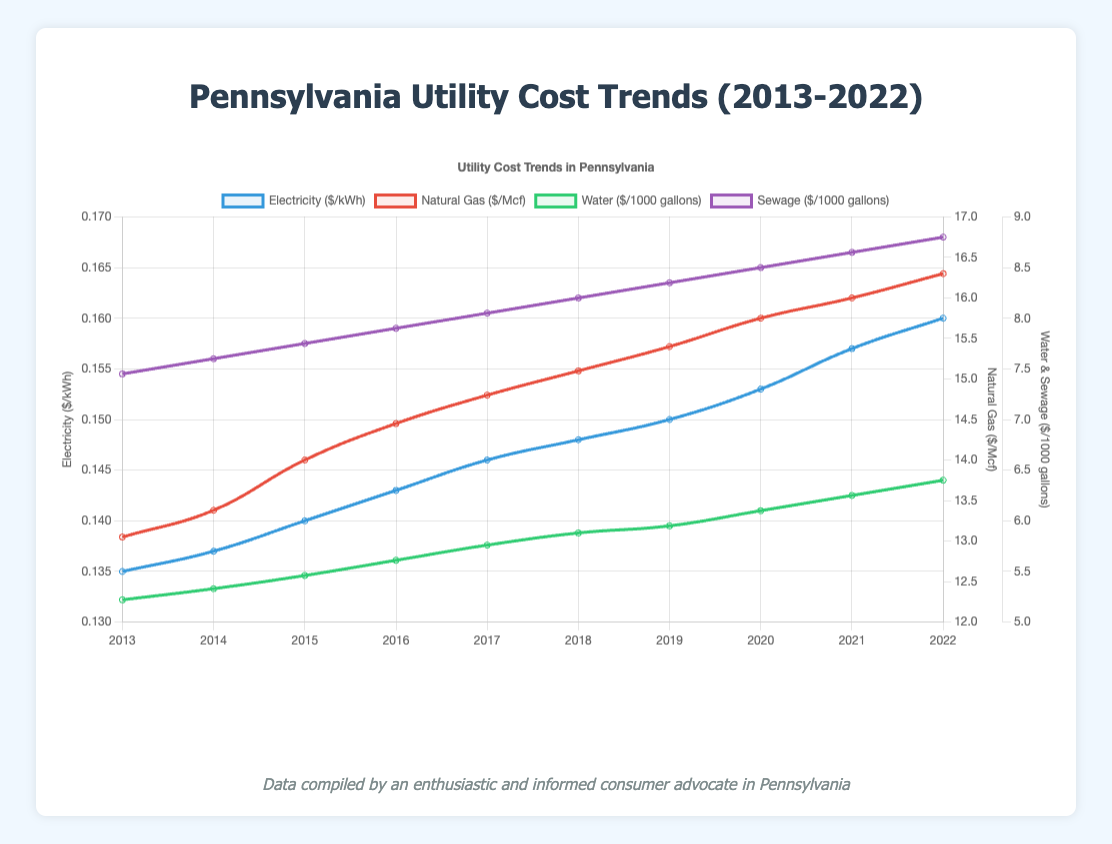Which utility had the highest cost in 2013? Observe the plot points for 2013. The values are: Electricity: 0.135 $/kWh, Natural Gas: 13.05 $/Mcf, Water: 5.22 $/1000 gallons, Sewage: 7.45 $/1000 gallons. Natural Gas is the highest.
Answer: Natural Gas How much did the cost of water increase from 2013 to 2022? Find the values for water in 2013 and 2022. Water cost in 2013 was 5.22 $/1000 gallons, and in 2022 it was 6.40 $/1000 gallons. The increase is 6.40 - 5.22 = 1.18 $/1000 gallons.
Answer: 1.18 $/1000 gallons Which utility cost grew the most between 2013 and 2022? Compare the differences in the costs of each utility between 2013 and 2022: Electricity (0.160 - 0.135 = 0.025 $/kWh), Natural Gas (16.30 - 13.05 = 3.25 $/Mcf), Water (6.40 - 5.22 = 1.18 $/1000 gallons), Sewage (8.80 - 7.45 = 1.35 $/1000 gallons). Natural Gas had the highest increase.
Answer: Natural Gas Is the trend line for electricity always increasing over the decade? Examine the trajectory of the electricity cost line from 2013 to 2022. The values are: 0.135, 0.137, 0.140, 0.143, 0.146, 0.148, 0.150, 0.153, 0.157, 0.160. Each year, the value increases.
Answer: Yes What was the average cost of sewage over the decade? Add the yearly costs of sewage: 7.45 + 7.60 + 7.75 + 7.90 + 8.05 + 8.20 + 8.35 + 8.50 + 8.65 + 8.80 = 78.25. Then divide by the number of years (10): 78.25 / 10 = 7.825 $/1000 gallons.
Answer: 7.825 $/1000 gallons Did water and sewage costs share the same trend in any specific year? Look at the yearly values for water and sewage. Each year from 2013 to 2022, both water and sewage costs increased, showing a shared positive trend.
Answer: Yes Compare the starting and ending costs of natural gas to water. How do they differ? Observe the values in 2013 and 2022 for Natural Gas (13.05, 16.30) and Water (5.22, 6.40). The difference for natural gas is 16.30 - 13.05 = 3.25, and for water, it is 6.40 - 5.22 = 1.18. Comparatively, the cost increase of natural gas is higher than water.
Answer: Natural gas increased more What is the median cost of water over the given years? Sort the water costs and find the middle value: 5.22, 5.33, 5.46, 5.61, 5.76, 5.88, 5.95, 6.10, 6.25, 6.40. The median is the average of the 5th and 6th values: (5.76 + 5.88) / 2 = 5.82 $/1000 gallons.
Answer: 5.82 $/1000 gallons 